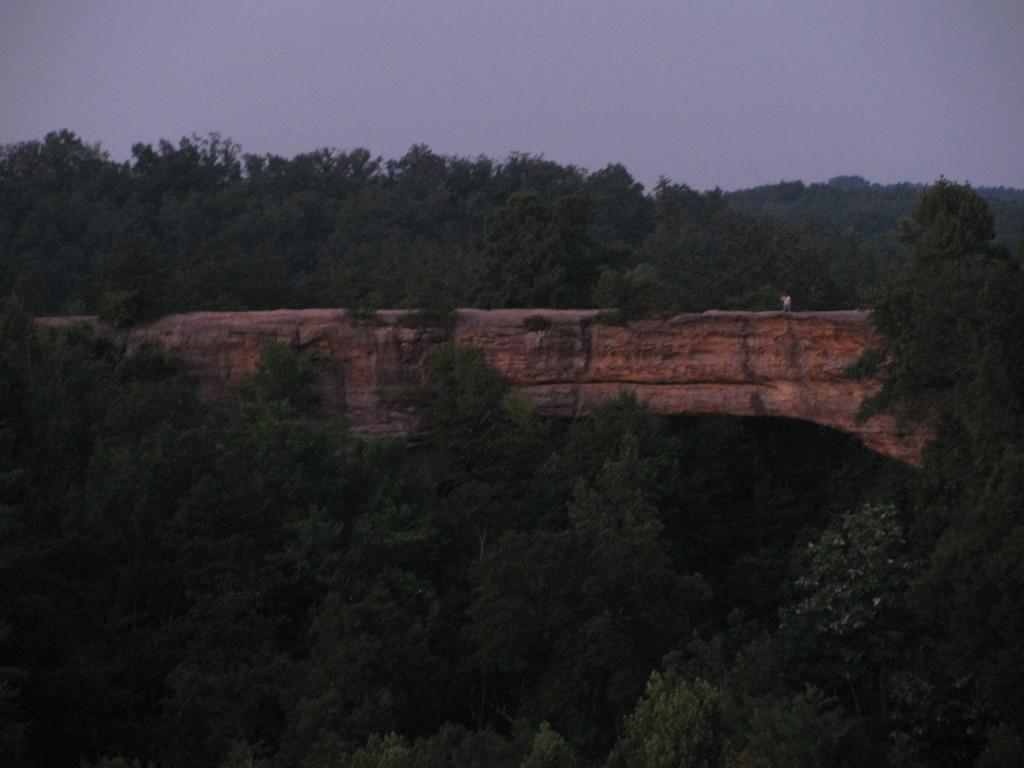What type of natural environment is depicted in the image? The image features many trees and a mountain, indicating a forest or mountainous area. Can you describe the sky in the image? The sky is visible at the top of the image, and clouds are present in the sky. What is the main geographical feature in the image? The mountain is the main geographical feature in the image. What type of gate can be seen at the entrance of the forest in the image? There is no gate present in the image; it features trees, a mountain, and a sky with clouds. 